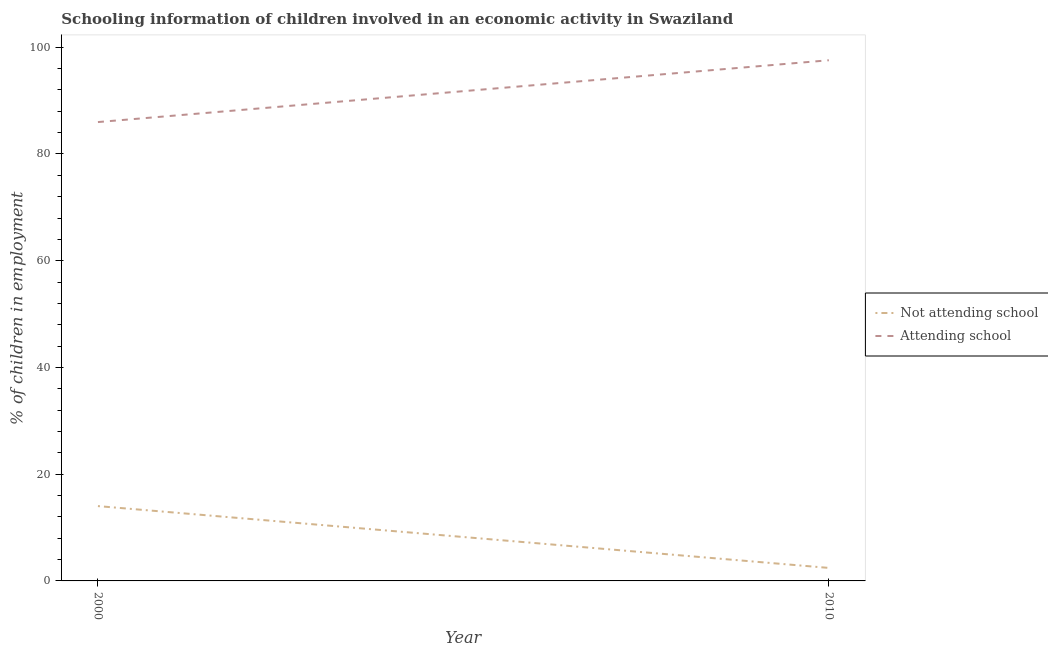How many different coloured lines are there?
Give a very brief answer. 2. What is the percentage of employed children who are attending school in 2010?
Give a very brief answer. 97.56. Across all years, what is the maximum percentage of employed children who are attending school?
Make the answer very short. 97.56. Across all years, what is the minimum percentage of employed children who are attending school?
Provide a short and direct response. 85.98. In which year was the percentage of employed children who are attending school maximum?
Provide a short and direct response. 2010. What is the total percentage of employed children who are not attending school in the graph?
Make the answer very short. 16.46. What is the difference between the percentage of employed children who are not attending school in 2000 and that in 2010?
Provide a succinct answer. 11.58. What is the difference between the percentage of employed children who are attending school in 2010 and the percentage of employed children who are not attending school in 2000?
Provide a short and direct response. 83.54. What is the average percentage of employed children who are attending school per year?
Give a very brief answer. 91.77. In the year 2010, what is the difference between the percentage of employed children who are not attending school and percentage of employed children who are attending school?
Make the answer very short. -95.13. What is the ratio of the percentage of employed children who are attending school in 2000 to that in 2010?
Offer a very short reply. 0.88. Is the percentage of employed children who are not attending school in 2000 less than that in 2010?
Keep it short and to the point. No. In how many years, is the percentage of employed children who are attending school greater than the average percentage of employed children who are attending school taken over all years?
Your answer should be very brief. 1. Is the percentage of employed children who are attending school strictly greater than the percentage of employed children who are not attending school over the years?
Offer a very short reply. Yes. Is the percentage of employed children who are attending school strictly less than the percentage of employed children who are not attending school over the years?
Make the answer very short. No. What is the difference between two consecutive major ticks on the Y-axis?
Keep it short and to the point. 20. Are the values on the major ticks of Y-axis written in scientific E-notation?
Make the answer very short. No. Does the graph contain any zero values?
Provide a succinct answer. No. Does the graph contain grids?
Ensure brevity in your answer.  No. What is the title of the graph?
Give a very brief answer. Schooling information of children involved in an economic activity in Swaziland. Does "current US$" appear as one of the legend labels in the graph?
Give a very brief answer. No. What is the label or title of the X-axis?
Keep it short and to the point. Year. What is the label or title of the Y-axis?
Provide a short and direct response. % of children in employment. What is the % of children in employment in Not attending school in 2000?
Offer a very short reply. 14.02. What is the % of children in employment in Attending school in 2000?
Your answer should be compact. 85.98. What is the % of children in employment in Not attending school in 2010?
Your response must be concise. 2.44. What is the % of children in employment of Attending school in 2010?
Your answer should be compact. 97.56. Across all years, what is the maximum % of children in employment in Not attending school?
Keep it short and to the point. 14.02. Across all years, what is the maximum % of children in employment in Attending school?
Make the answer very short. 97.56. Across all years, what is the minimum % of children in employment in Not attending school?
Your response must be concise. 2.44. Across all years, what is the minimum % of children in employment in Attending school?
Keep it short and to the point. 85.98. What is the total % of children in employment of Not attending school in the graph?
Ensure brevity in your answer.  16.46. What is the total % of children in employment in Attending school in the graph?
Give a very brief answer. 183.54. What is the difference between the % of children in employment in Not attending school in 2000 and that in 2010?
Provide a short and direct response. 11.58. What is the difference between the % of children in employment in Attending school in 2000 and that in 2010?
Ensure brevity in your answer.  -11.58. What is the difference between the % of children in employment of Not attending school in 2000 and the % of children in employment of Attending school in 2010?
Your answer should be compact. -83.54. What is the average % of children in employment in Not attending school per year?
Your response must be concise. 8.23. What is the average % of children in employment in Attending school per year?
Give a very brief answer. 91.77. In the year 2000, what is the difference between the % of children in employment of Not attending school and % of children in employment of Attending school?
Offer a very short reply. -71.96. In the year 2010, what is the difference between the % of children in employment in Not attending school and % of children in employment in Attending school?
Your answer should be very brief. -95.13. What is the ratio of the % of children in employment of Not attending school in 2000 to that in 2010?
Offer a very short reply. 5.75. What is the ratio of the % of children in employment of Attending school in 2000 to that in 2010?
Make the answer very short. 0.88. What is the difference between the highest and the second highest % of children in employment in Not attending school?
Make the answer very short. 11.58. What is the difference between the highest and the second highest % of children in employment of Attending school?
Make the answer very short. 11.58. What is the difference between the highest and the lowest % of children in employment in Not attending school?
Provide a short and direct response. 11.58. What is the difference between the highest and the lowest % of children in employment of Attending school?
Keep it short and to the point. 11.58. 